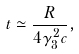<formula> <loc_0><loc_0><loc_500><loc_500>t \simeq \frac { R } { 4 \gamma _ { 3 } ^ { 2 } c } ,</formula> 